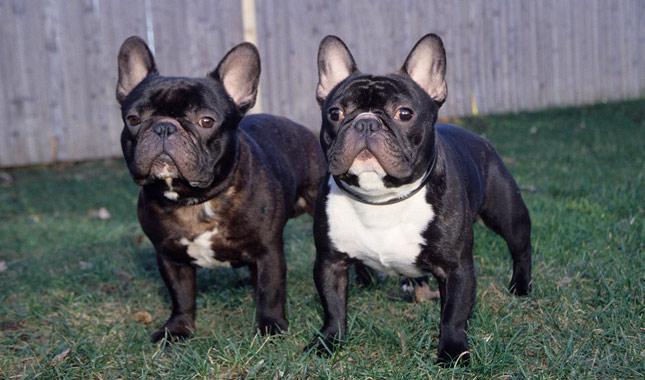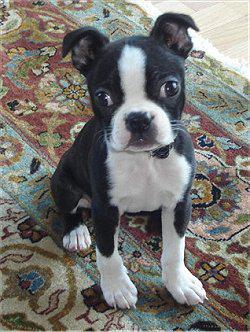The first image is the image on the left, the second image is the image on the right. Examine the images to the left and right. Is the description "The dog in the image on the left is inside." accurate? Answer yes or no. No. The first image is the image on the left, the second image is the image on the right. Examine the images to the left and right. Is the description "At least one big-eared bulldog is standing on all fours on green grass, facing toward the camera." accurate? Answer yes or no. Yes. The first image is the image on the left, the second image is the image on the right. Analyze the images presented: Is the assertion "One image features exactly two dogs posed close together and facing  forward." valid? Answer yes or no. Yes. The first image is the image on the left, the second image is the image on the right. For the images displayed, is the sentence "There are three dogs" factually correct? Answer yes or no. Yes. 